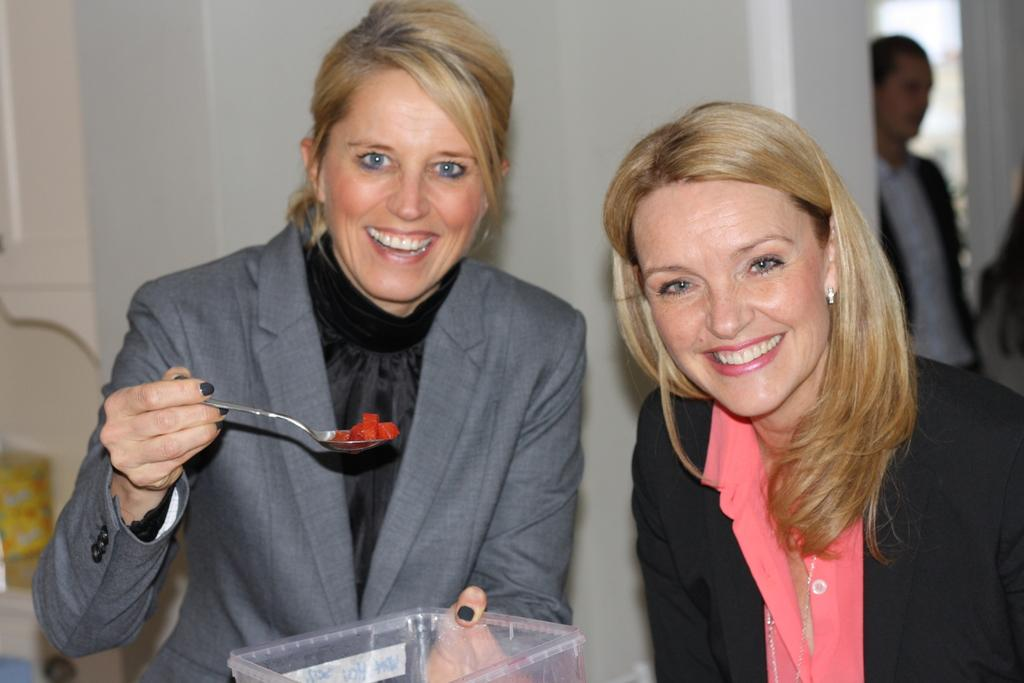How many women are present in the image? There are two women standing in the image. What are the women holding in their hands? One of the women is holding a spoon, and the other is holding a box. Can you describe the background of the image? There is a person and a wall visible in the background of the image. What type of screw can be seen on the wall in the image? There is no screw visible on the wall in the image. How does the earth appear in the image? The image does not show the earth; it only shows two women, a spoon, a box, a person, and a wall. 